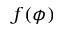<formula> <loc_0><loc_0><loc_500><loc_500>f ( \phi )</formula> 